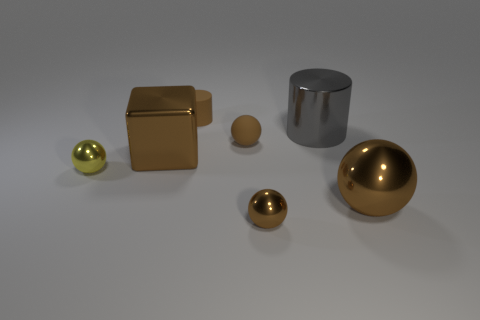Is there a large object that has the same color as the tiny rubber cylinder?
Ensure brevity in your answer.  Yes. There is a metallic sphere that is the same size as the metal block; what color is it?
Provide a succinct answer. Brown. How many tiny things are either brown shiny cubes or green matte cylinders?
Offer a very short reply. 0. Are there the same number of tiny things in front of the large brown shiny block and tiny brown shiny objects that are behind the matte cylinder?
Offer a terse response. No. How many balls are the same size as the gray cylinder?
Give a very brief answer. 1. What number of gray objects are either cubes or balls?
Offer a very short reply. 0. Are there an equal number of yellow objects that are to the right of the brown cube and big blue metallic cylinders?
Ensure brevity in your answer.  Yes. How big is the matte object that is in front of the small matte cylinder?
Provide a short and direct response. Small. What number of yellow things have the same shape as the big gray thing?
Your response must be concise. 0. There is a brown thing that is both left of the brown rubber ball and on the right side of the large brown block; what is it made of?
Your answer should be compact. Rubber. 